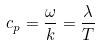Convert formula to latex. <formula><loc_0><loc_0><loc_500><loc_500>c _ { p } = \frac { \omega } { k } = \frac { \lambda } { T }</formula> 